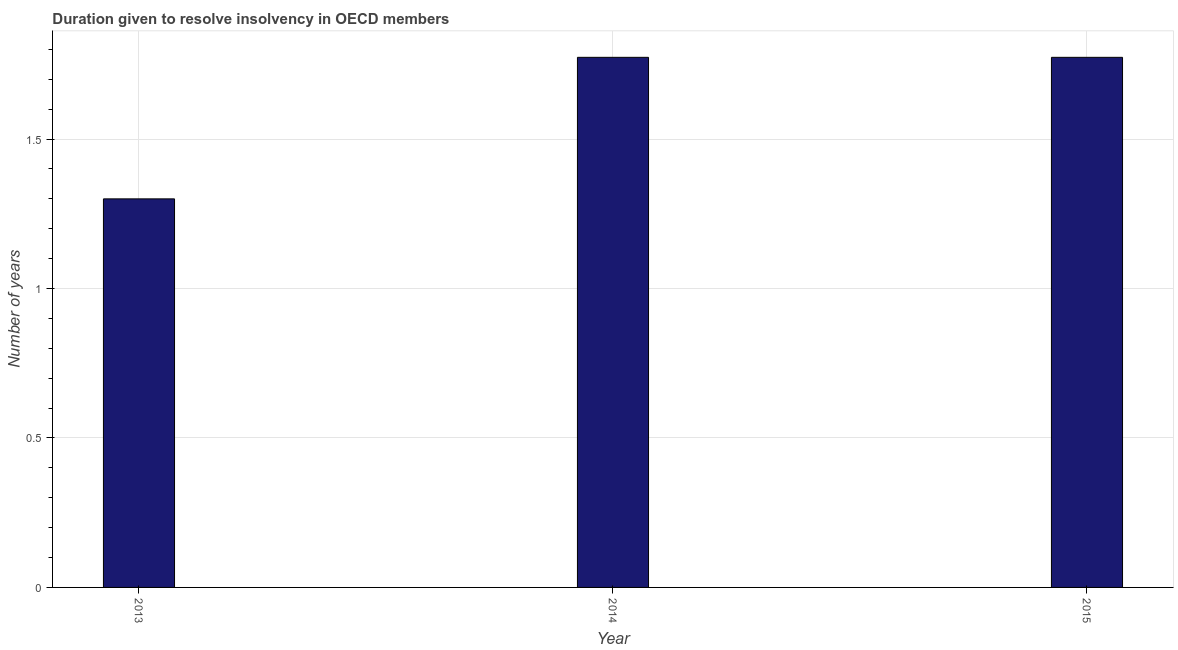Does the graph contain grids?
Offer a terse response. Yes. What is the title of the graph?
Ensure brevity in your answer.  Duration given to resolve insolvency in OECD members. What is the label or title of the X-axis?
Give a very brief answer. Year. What is the label or title of the Y-axis?
Make the answer very short. Number of years. What is the number of years to resolve insolvency in 2014?
Your answer should be compact. 1.77. Across all years, what is the maximum number of years to resolve insolvency?
Your answer should be compact. 1.77. Across all years, what is the minimum number of years to resolve insolvency?
Give a very brief answer. 1.3. In which year was the number of years to resolve insolvency maximum?
Ensure brevity in your answer.  2014. In which year was the number of years to resolve insolvency minimum?
Offer a very short reply. 2013. What is the sum of the number of years to resolve insolvency?
Your answer should be very brief. 4.85. What is the difference between the number of years to resolve insolvency in 2014 and 2015?
Ensure brevity in your answer.  0. What is the average number of years to resolve insolvency per year?
Make the answer very short. 1.62. What is the median number of years to resolve insolvency?
Give a very brief answer. 1.77. In how many years, is the number of years to resolve insolvency greater than 1.6 ?
Give a very brief answer. 2. Do a majority of the years between 2015 and 2013 (inclusive) have number of years to resolve insolvency greater than 0.9 ?
Provide a short and direct response. Yes. What is the ratio of the number of years to resolve insolvency in 2013 to that in 2014?
Offer a very short reply. 0.73. Is the sum of the number of years to resolve insolvency in 2014 and 2015 greater than the maximum number of years to resolve insolvency across all years?
Make the answer very short. Yes. What is the difference between the highest and the lowest number of years to resolve insolvency?
Give a very brief answer. 0.47. How many bars are there?
Give a very brief answer. 3. Are all the bars in the graph horizontal?
Provide a short and direct response. No. What is the difference between two consecutive major ticks on the Y-axis?
Keep it short and to the point. 0.5. What is the Number of years in 2013?
Provide a succinct answer. 1.3. What is the Number of years in 2014?
Your answer should be compact. 1.77. What is the Number of years of 2015?
Provide a short and direct response. 1.77. What is the difference between the Number of years in 2013 and 2014?
Your answer should be compact. -0.47. What is the difference between the Number of years in 2013 and 2015?
Your response must be concise. -0.47. What is the ratio of the Number of years in 2013 to that in 2014?
Offer a terse response. 0.73. What is the ratio of the Number of years in 2013 to that in 2015?
Make the answer very short. 0.73. 